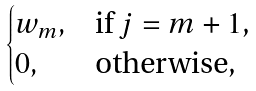<formula> <loc_0><loc_0><loc_500><loc_500>\begin{cases} { w } _ { m } , & \text {if $j=m+1$,} \\ 0 , & \text {otherwise,} \end{cases}</formula> 